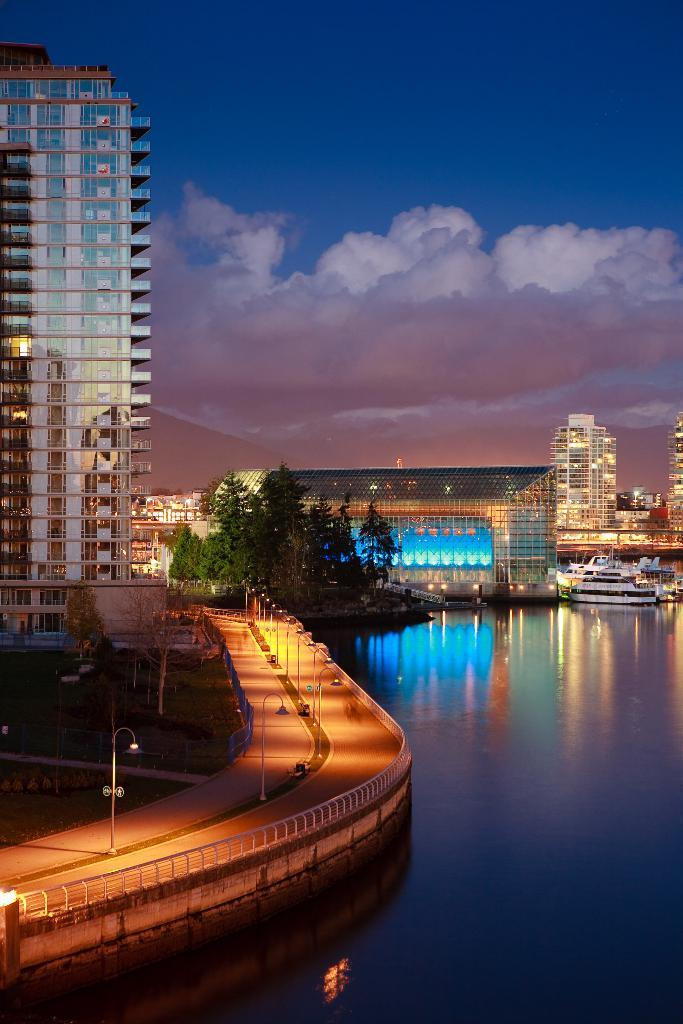What type of natural feature is present in the image? There is a river in the image. What is located near the river? There is a road beside the river. What can be seen in the background of the image? There are trees and buildings in the background of the image. What is the color of the sky in the image? The sky is blue in the image. What type of government is depicted in the image? There is no depiction of a government in the image; it features a river, road, trees, buildings, and a blue sky. What sound can be heard coming from the river in the image? There is no sound present in the image, as it is a static representation. 